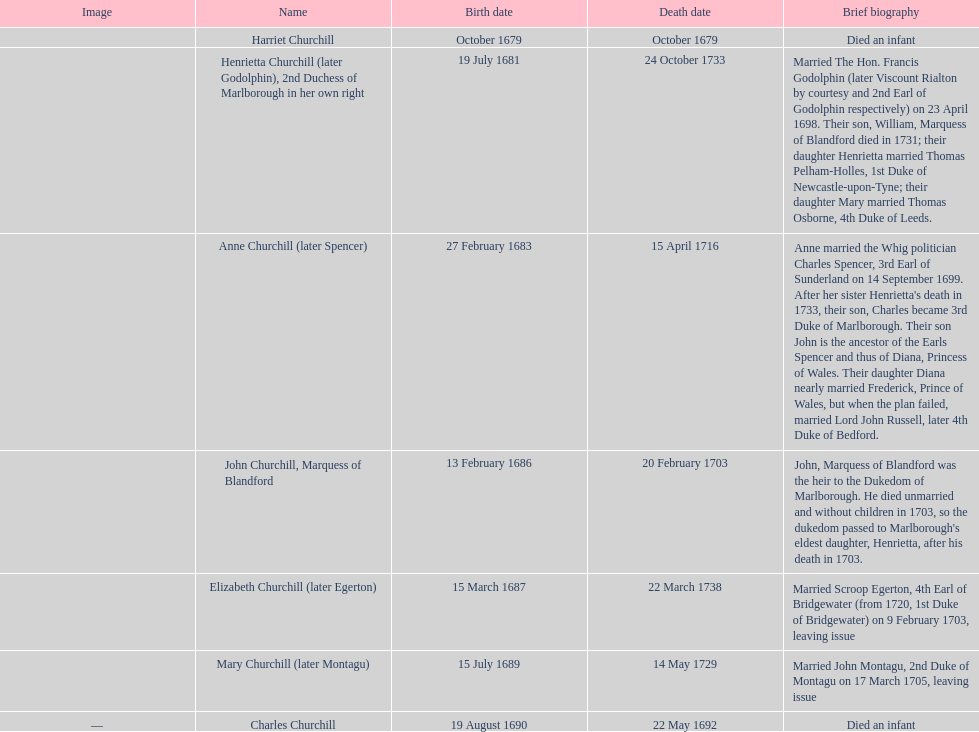Which kid came into the world after elizabeth churchill? Mary Churchill. Give me the full table as a dictionary. {'header': ['Image', 'Name', 'Birth date', 'Death date', 'Brief biography'], 'rows': [['', 'Harriet Churchill', 'October 1679', 'October 1679', 'Died an infant'], ['', 'Henrietta Churchill (later Godolphin), 2nd Duchess of Marlborough in her own right', '19 July 1681', '24 October 1733', 'Married The Hon. Francis Godolphin (later Viscount Rialton by courtesy and 2nd Earl of Godolphin respectively) on 23 April 1698. Their son, William, Marquess of Blandford died in 1731; their daughter Henrietta married Thomas Pelham-Holles, 1st Duke of Newcastle-upon-Tyne; their daughter Mary married Thomas Osborne, 4th Duke of Leeds.'], ['', 'Anne Churchill (later Spencer)', '27 February 1683', '15 April 1716', "Anne married the Whig politician Charles Spencer, 3rd Earl of Sunderland on 14 September 1699. After her sister Henrietta's death in 1733, their son, Charles became 3rd Duke of Marlborough. Their son John is the ancestor of the Earls Spencer and thus of Diana, Princess of Wales. Their daughter Diana nearly married Frederick, Prince of Wales, but when the plan failed, married Lord John Russell, later 4th Duke of Bedford."], ['', 'John Churchill, Marquess of Blandford', '13 February 1686', '20 February 1703', "John, Marquess of Blandford was the heir to the Dukedom of Marlborough. He died unmarried and without children in 1703, so the dukedom passed to Marlborough's eldest daughter, Henrietta, after his death in 1703."], ['', 'Elizabeth Churchill (later Egerton)', '15 March 1687', '22 March 1738', 'Married Scroop Egerton, 4th Earl of Bridgewater (from 1720, 1st Duke of Bridgewater) on 9 February 1703, leaving issue'], ['', 'Mary Churchill (later Montagu)', '15 July 1689', '14 May 1729', 'Married John Montagu, 2nd Duke of Montagu on 17 March 1705, leaving issue'], ['—', 'Charles Churchill', '19 August 1690', '22 May 1692', 'Died an infant']]} 